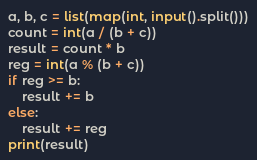<code> <loc_0><loc_0><loc_500><loc_500><_Python_>a, b, c = list(map(int, input().split()))
count = int(a / (b + c))
result = count * b
reg = int(a % (b + c))
if reg >= b:
    result += b
else:
    result += reg
print(result)</code> 